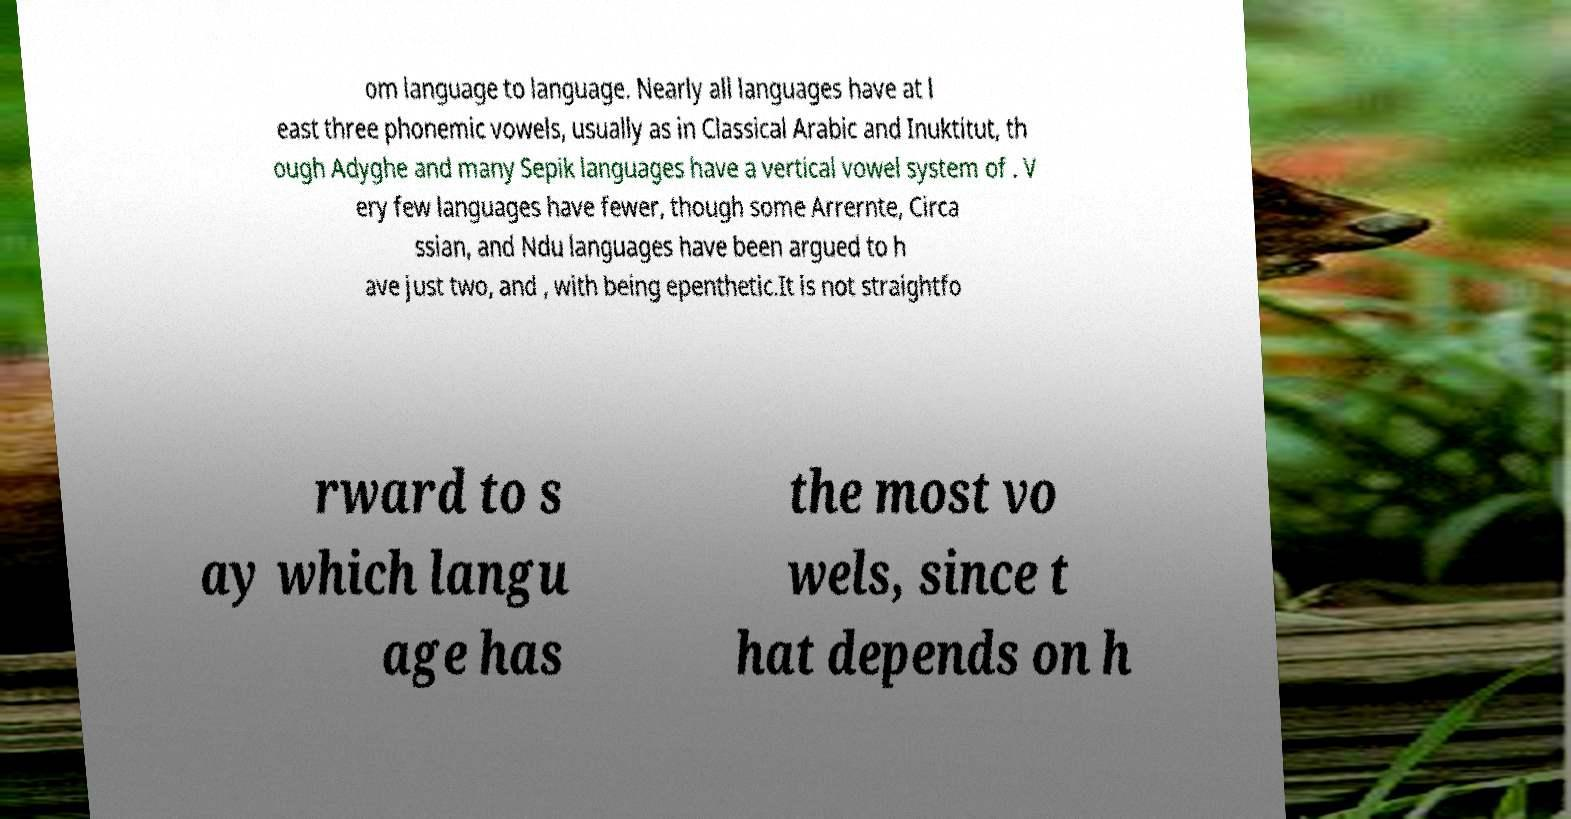For documentation purposes, I need the text within this image transcribed. Could you provide that? om language to language. Nearly all languages have at l east three phonemic vowels, usually as in Classical Arabic and Inuktitut, th ough Adyghe and many Sepik languages have a vertical vowel system of . V ery few languages have fewer, though some Arrernte, Circa ssian, and Ndu languages have been argued to h ave just two, and , with being epenthetic.It is not straightfo rward to s ay which langu age has the most vo wels, since t hat depends on h 